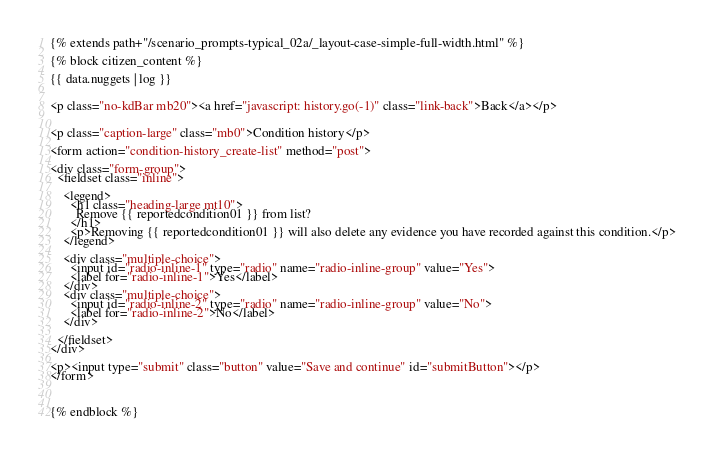Convert code to text. <code><loc_0><loc_0><loc_500><loc_500><_HTML_>{% extends path+"/scenario_prompts-typical_02a/_layout-case-simple-full-width.html" %}

{% block citizen_content %}

{{ data.nuggets | log }}


<p class="no-kdBar mb20"><a href="javascript: history.go(-1)" class="link-back">Back</a></p>


<p class="caption-large" class="mb0">Condition history</p>

<form action="condition-history_create-list" method="post">

<div class="form-group">
  <fieldset class="inline">

    <legend>
      <h1 class="heading-large mt10">
        Remove {{ reportedcondition01 }} from list?
      </h1>
      <p>Removing {{ reportedcondition01 }} will also delete any evidence you have recorded against this condition.</p>
    </legend>

    <div class="multiple-choice">
      <input id="radio-inline-1" type="radio" name="radio-inline-group" value="Yes">
      <label for="radio-inline-1">Yes</label>
    </div>
    <div class="multiple-choice">
      <input id="radio-inline-2" type="radio" name="radio-inline-group" value="No">
      <label for="radio-inline-2">No</label>
    </div>

  </fieldset>
</div>

<p><input type="submit" class="button" value="Save and continue" id="submitButton"></p>
</form>



{% endblock %}</code> 